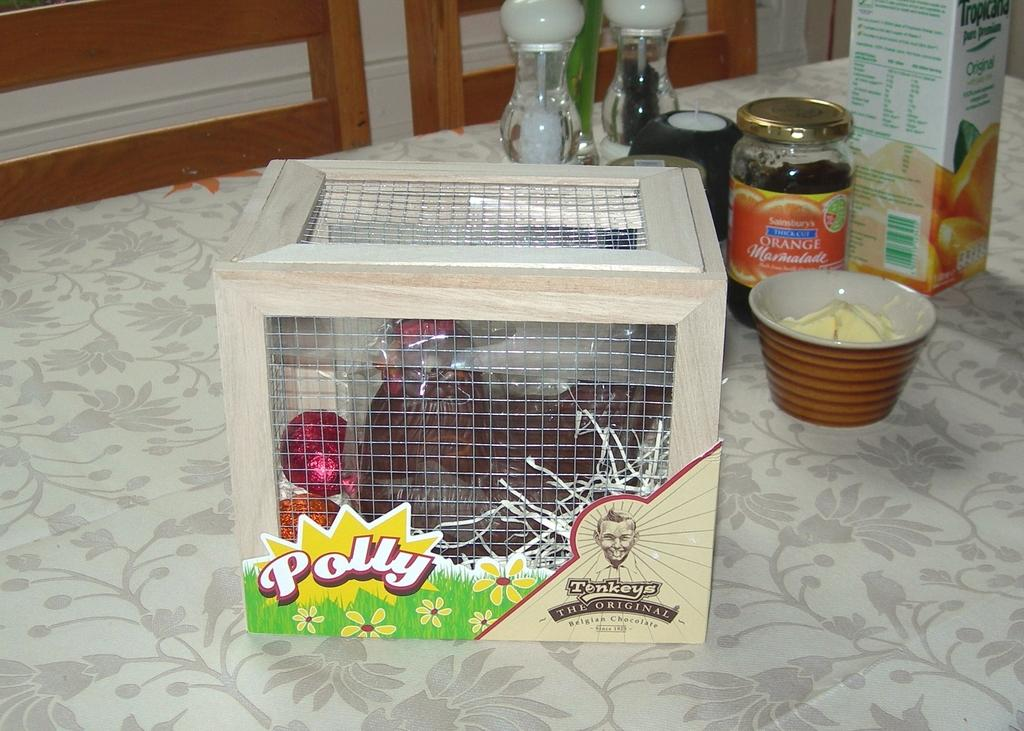<image>
Offer a succinct explanation of the picture presented. A box of Tenkey's original Belgian Chocolates sitting on a table. 